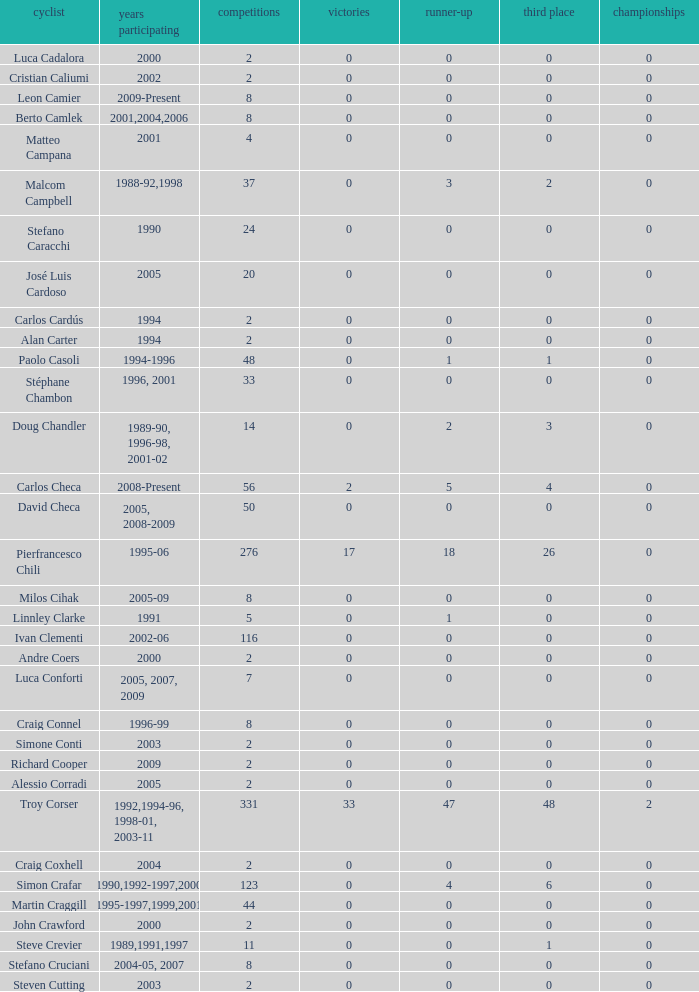What is the total number of wins for riders with fewer than 56 races and more than 0 titles? 0.0. 